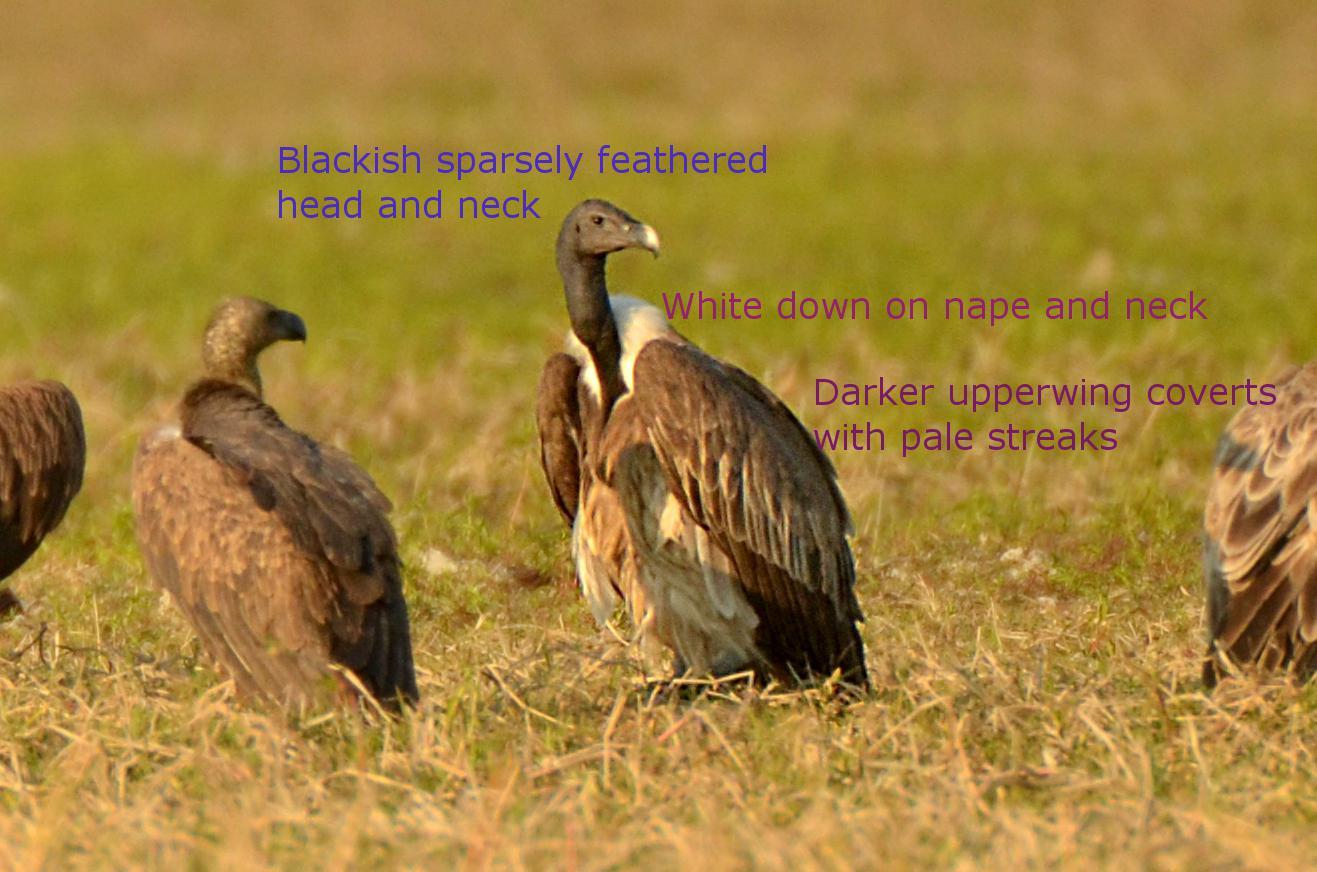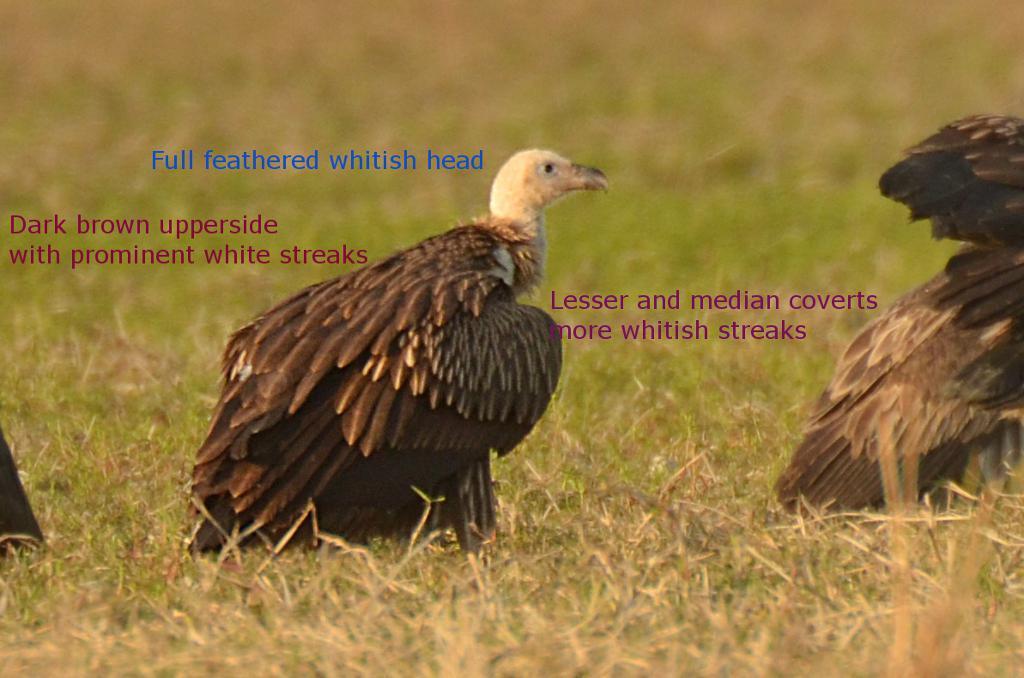The first image is the image on the left, the second image is the image on the right. For the images shown, is this caption "In all images at least one bird has its wings open, and in one image that bird is on the ground and in the other it is in the air." true? Answer yes or no. No. 